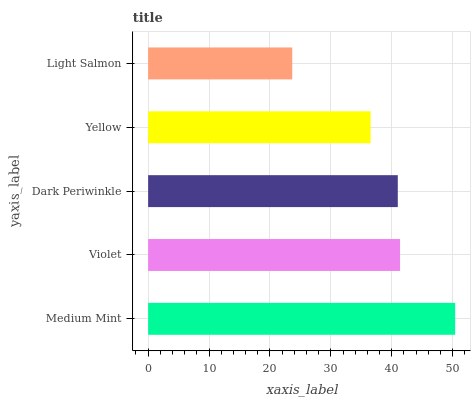Is Light Salmon the minimum?
Answer yes or no. Yes. Is Medium Mint the maximum?
Answer yes or no. Yes. Is Violet the minimum?
Answer yes or no. No. Is Violet the maximum?
Answer yes or no. No. Is Medium Mint greater than Violet?
Answer yes or no. Yes. Is Violet less than Medium Mint?
Answer yes or no. Yes. Is Violet greater than Medium Mint?
Answer yes or no. No. Is Medium Mint less than Violet?
Answer yes or no. No. Is Dark Periwinkle the high median?
Answer yes or no. Yes. Is Dark Periwinkle the low median?
Answer yes or no. Yes. Is Violet the high median?
Answer yes or no. No. Is Violet the low median?
Answer yes or no. No. 